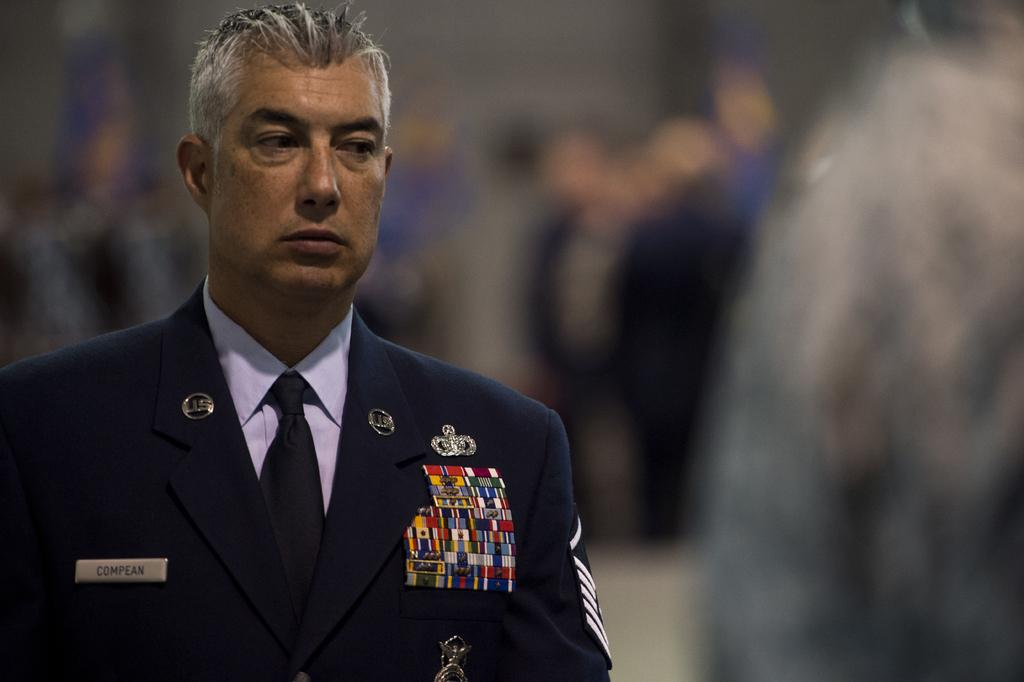Who or what can be seen in the image? There is a person in the image. What is the person wearing? The person is wearing a costume. Can you describe the background of the image? The background of the image is blurred. What type of dinner is being served in the image? There is no dinner present in the image; it features a person wearing a costume with a blurred background. 